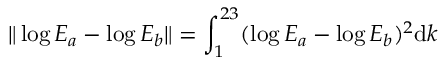Convert formula to latex. <formula><loc_0><loc_0><loc_500><loc_500>\| \log E _ { a } - \log E _ { b } \| = \int _ { 1 } ^ { 2 3 } ( \log E _ { a } - \log E _ { b } ) ^ { 2 } d k</formula> 